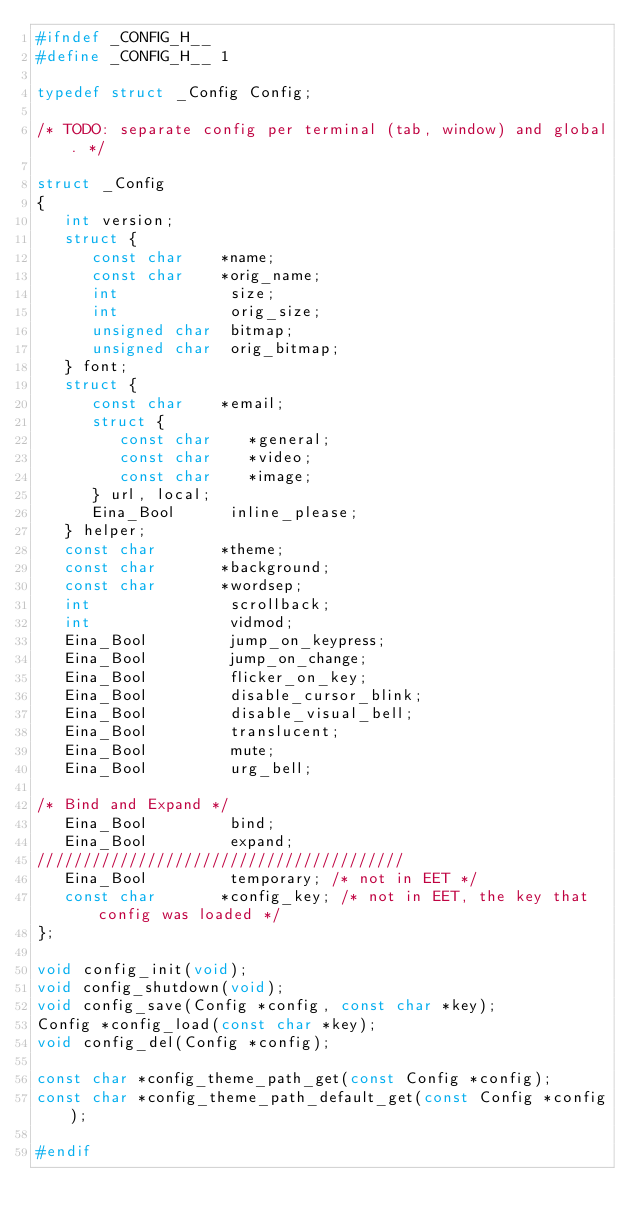Convert code to text. <code><loc_0><loc_0><loc_500><loc_500><_C_>#ifndef _CONFIG_H__
#define _CONFIG_H__ 1

typedef struct _Config Config;

/* TODO: separate config per terminal (tab, window) and global. */

struct _Config
{
   int version;
   struct {
      const char    *name;
      const char    *orig_name;
      int            size;
      int            orig_size;
      unsigned char  bitmap;
      unsigned char  orig_bitmap;
   } font;
   struct {
      const char    *email;
      struct {
         const char    *general;
         const char    *video;
         const char    *image;
      } url, local;
      Eina_Bool      inline_please;
   } helper;
   const char       *theme;
   const char       *background;
   const char       *wordsep;
   int               scrollback;
   int               vidmod;
   Eina_Bool         jump_on_keypress;
   Eina_Bool         jump_on_change;
   Eina_Bool         flicker_on_key;
   Eina_Bool         disable_cursor_blink;
   Eina_Bool         disable_visual_bell;
   Eina_Bool         translucent;
   Eina_Bool         mute;
   Eina_Bool         urg_bell;

/* Bind and Expand */
   Eina_Bool         bind;
   Eina_Bool         expand;
////////////////////////////////////////  
   Eina_Bool         temporary; /* not in EET */
   const char       *config_key; /* not in EET, the key that config was loaded */
};

void config_init(void);
void config_shutdown(void);
void config_save(Config *config, const char *key);
Config *config_load(const char *key);
void config_del(Config *config);

const char *config_theme_path_get(const Config *config);
const char *config_theme_path_default_get(const Config *config);

#endif
</code> 